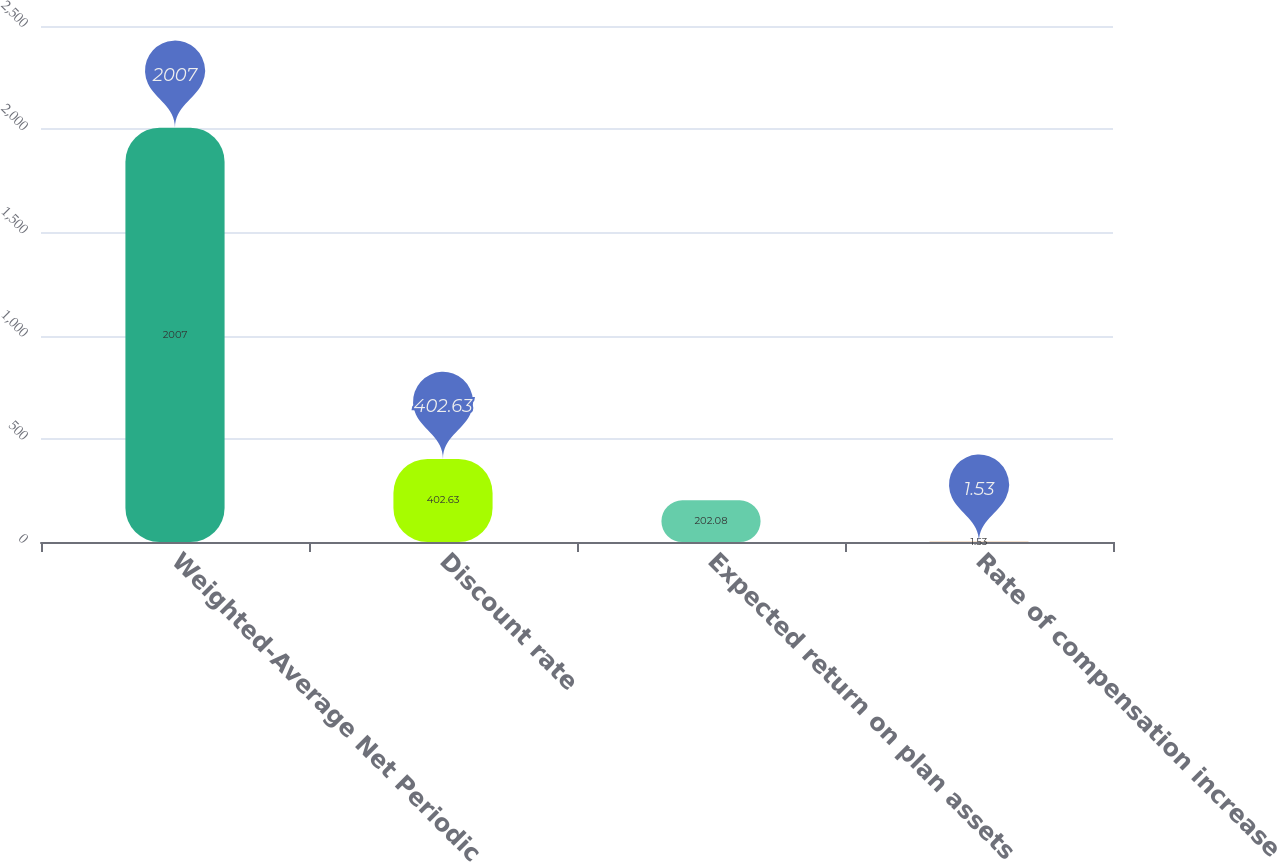Convert chart to OTSL. <chart><loc_0><loc_0><loc_500><loc_500><bar_chart><fcel>Weighted-Average Net Periodic<fcel>Discount rate<fcel>Expected return on plan assets<fcel>Rate of compensation increase<nl><fcel>2007<fcel>402.63<fcel>202.08<fcel>1.53<nl></chart> 